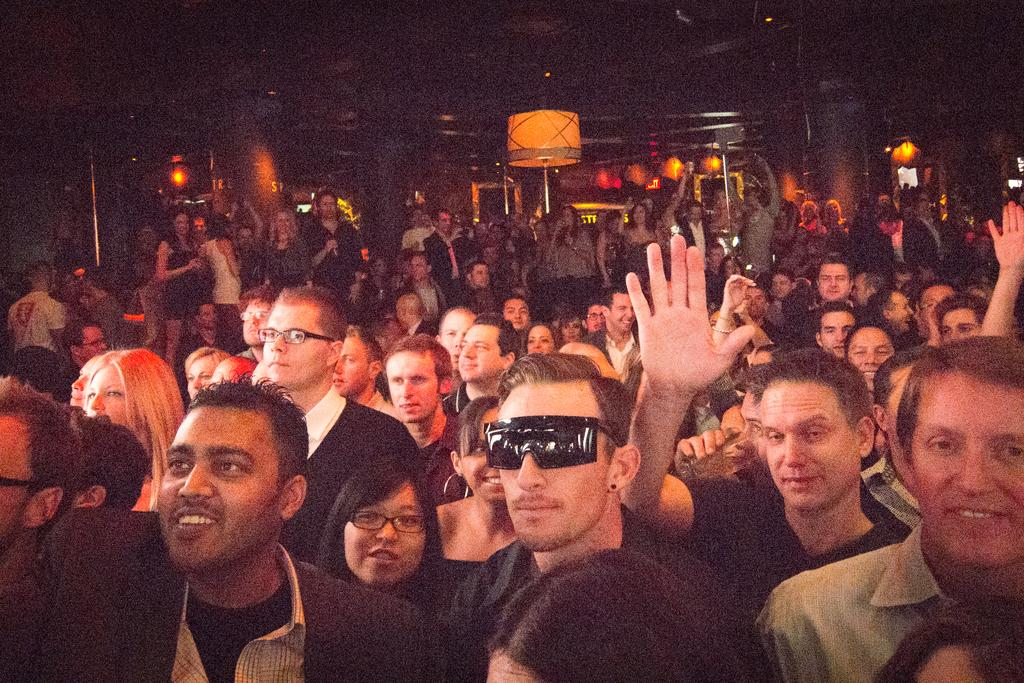What objects are present in the image that provide illumination? There are lights in the image. What structures can be seen in the image that support the lights? There are poles in the image. Who or what is visible in the image besides the lights and poles? There is a group of people in the image. How would you describe the overall brightness of the image? The image is dark. What is the distance between the school and the lights in the image? There is no reference to a school in the image, so it is not possible to determine the distance between the school and the lights. 